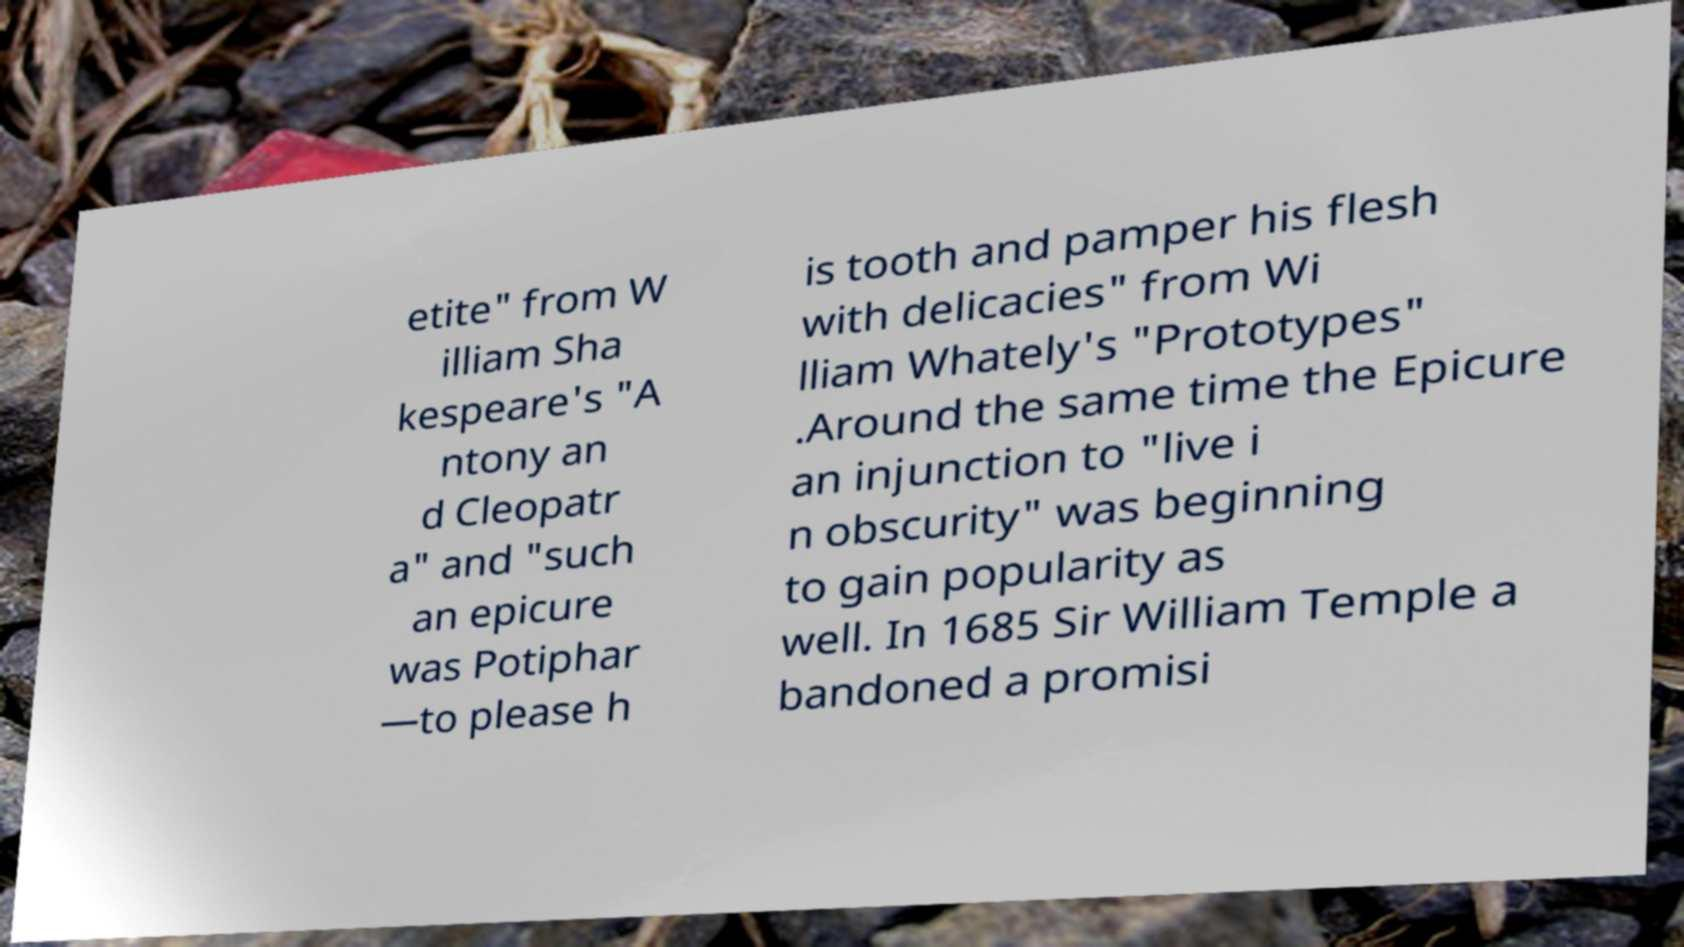Can you read and provide the text displayed in the image?This photo seems to have some interesting text. Can you extract and type it out for me? etite" from W illiam Sha kespeare's "A ntony an d Cleopatr a" and "such an epicure was Potiphar —to please h is tooth and pamper his flesh with delicacies" from Wi lliam Whately's "Prototypes" .Around the same time the Epicure an injunction to "live i n obscurity" was beginning to gain popularity as well. In 1685 Sir William Temple a bandoned a promisi 